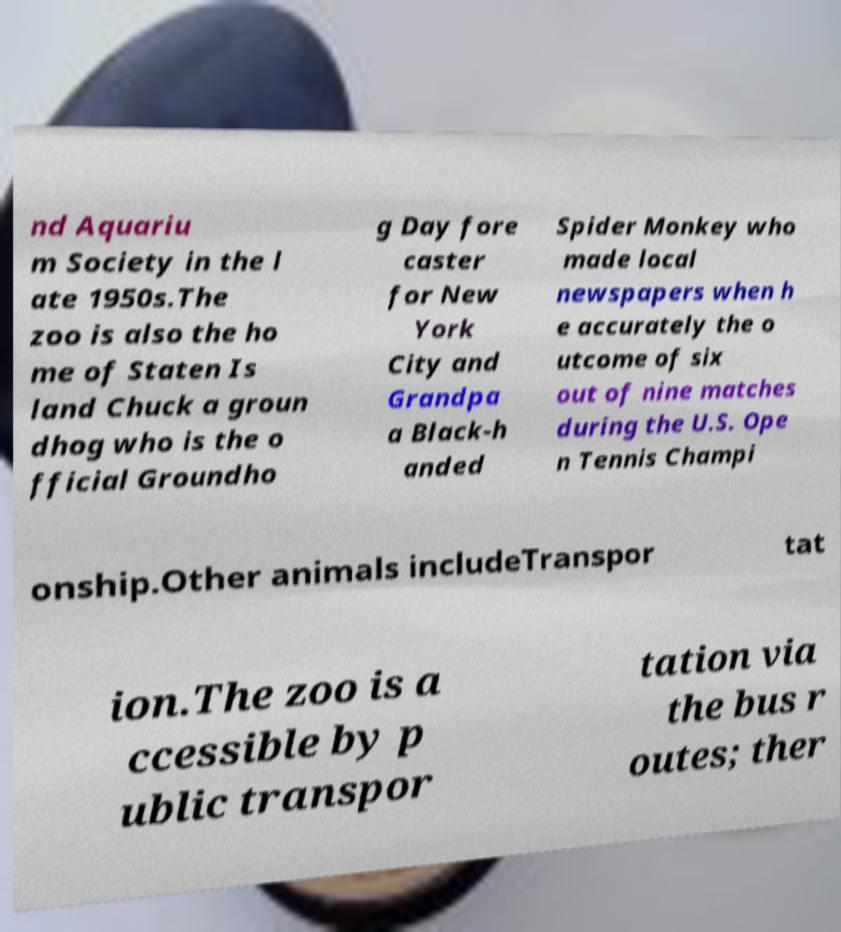Please read and relay the text visible in this image. What does it say? nd Aquariu m Society in the l ate 1950s.The zoo is also the ho me of Staten Is land Chuck a groun dhog who is the o fficial Groundho g Day fore caster for New York City and Grandpa a Black-h anded Spider Monkey who made local newspapers when h e accurately the o utcome of six out of nine matches during the U.S. Ope n Tennis Champi onship.Other animals includeTranspor tat ion.The zoo is a ccessible by p ublic transpor tation via the bus r outes; ther 